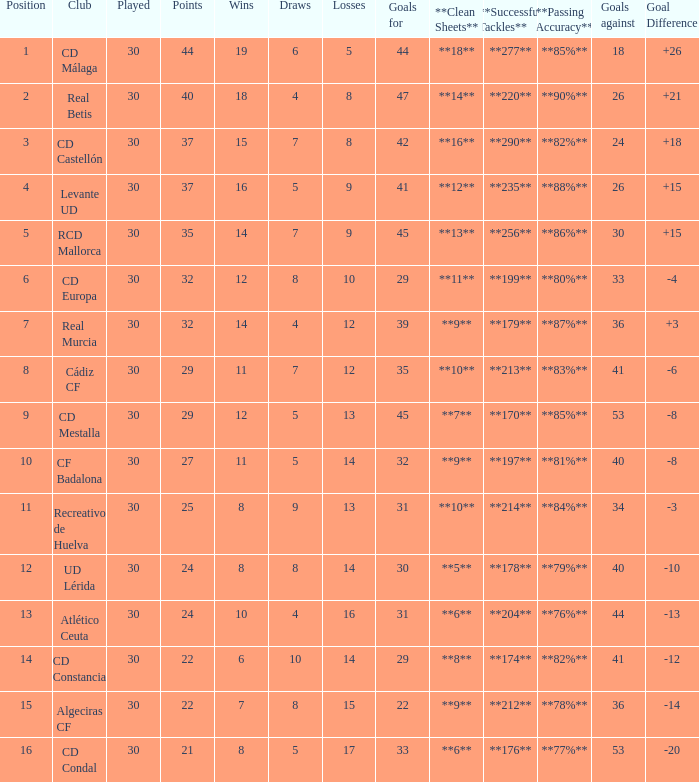What is the losses when the goal difference is larger than 26? None. 